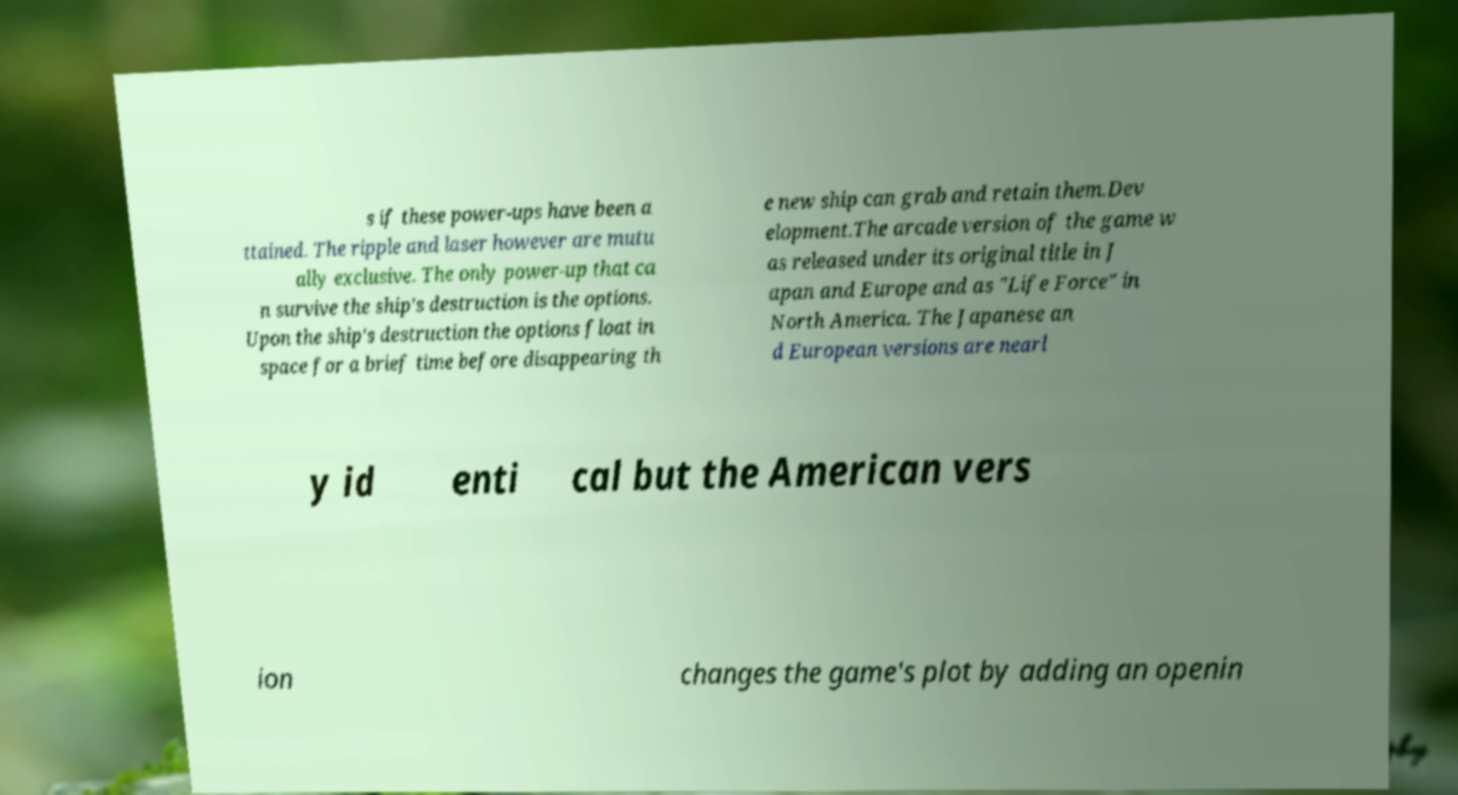Can you accurately transcribe the text from the provided image for me? s if these power-ups have been a ttained. The ripple and laser however are mutu ally exclusive. The only power-up that ca n survive the ship's destruction is the options. Upon the ship's destruction the options float in space for a brief time before disappearing th e new ship can grab and retain them.Dev elopment.The arcade version of the game w as released under its original title in J apan and Europe and as "Life Force" in North America. The Japanese an d European versions are nearl y id enti cal but the American vers ion changes the game's plot by adding an openin 